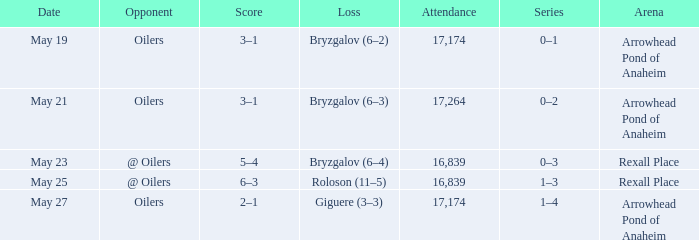With an 11-5 loss of roloson, what is the number of people in attendance? 16839.0. 